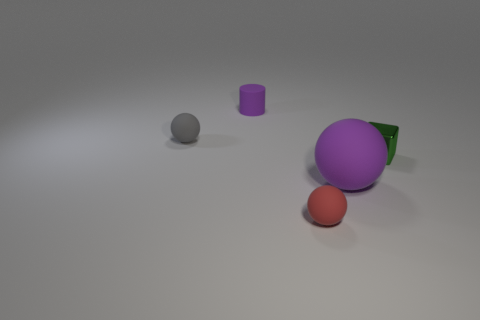Are there any other things that have the same size as the purple matte sphere?
Provide a short and direct response. No. Do the small sphere behind the big sphere and the cube have the same material?
Your answer should be very brief. No. Are any small purple rubber objects visible?
Keep it short and to the point. Yes. There is a ball that is both right of the small matte cylinder and to the left of the large purple ball; what is its size?
Make the answer very short. Small. Are there more red matte objects that are on the left side of the small purple cylinder than small shiny things left of the purple matte sphere?
Ensure brevity in your answer.  No. What is the size of the ball that is the same color as the rubber cylinder?
Provide a short and direct response. Large. The big matte sphere has what color?
Your answer should be very brief. Purple. What color is the matte thing that is both in front of the rubber cylinder and behind the big purple rubber thing?
Offer a terse response. Gray. What is the color of the small ball that is in front of the ball that is on the right side of the thing that is in front of the large thing?
Your answer should be compact. Red. There is a matte cylinder that is the same size as the green metallic cube; what color is it?
Ensure brevity in your answer.  Purple. 